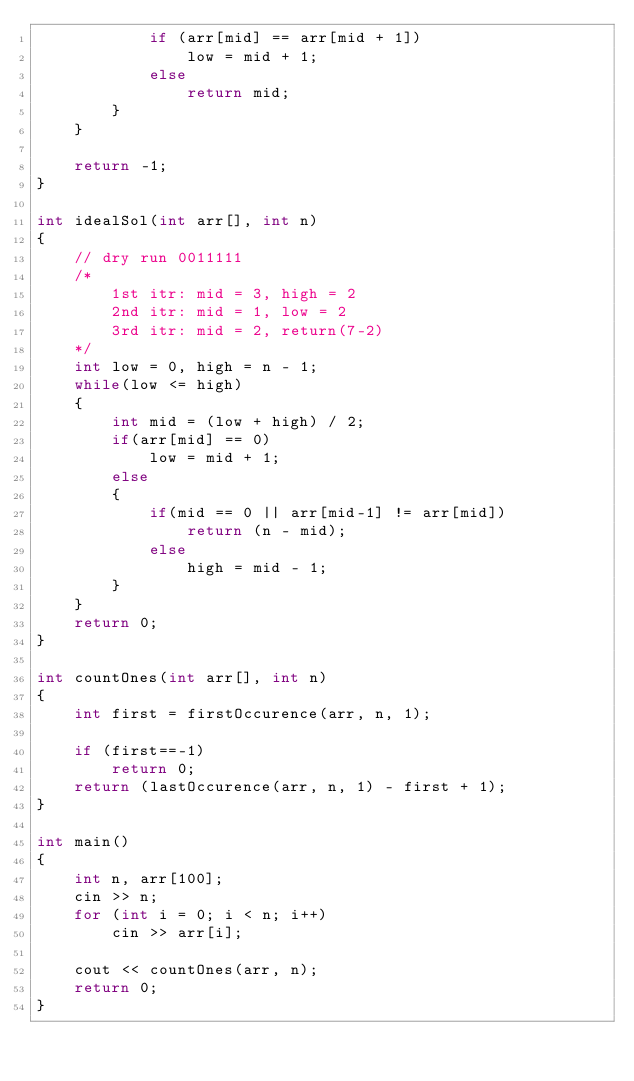<code> <loc_0><loc_0><loc_500><loc_500><_C++_>            if (arr[mid] == arr[mid + 1])
                low = mid + 1;
            else
                return mid;
        }
    }

    return -1;
}

int idealSol(int arr[], int n)
{
    // dry run 0011111
    /*
        1st itr: mid = 3, high = 2
        2nd itr: mid = 1, low = 2
        3rd itr: mid = 2, return(7-2)
    */
    int low = 0, high = n - 1;
    while(low <= high)
    {
        int mid = (low + high) / 2;
        if(arr[mid] == 0)
            low = mid + 1;
        else 
        {
            if(mid == 0 || arr[mid-1] != arr[mid])
                return (n - mid);
            else
                high = mid - 1;
        }
    }
    return 0;
}

int countOnes(int arr[], int n)
{
    int first = firstOccurence(arr, n, 1);

    if (first==-1)
        return 0;
    return (lastOccurence(arr, n, 1) - first + 1);
}

int main()
{
    int n, arr[100];
    cin >> n;
    for (int i = 0; i < n; i++)
        cin >> arr[i];

    cout << countOnes(arr, n);
    return 0;
}
</code> 